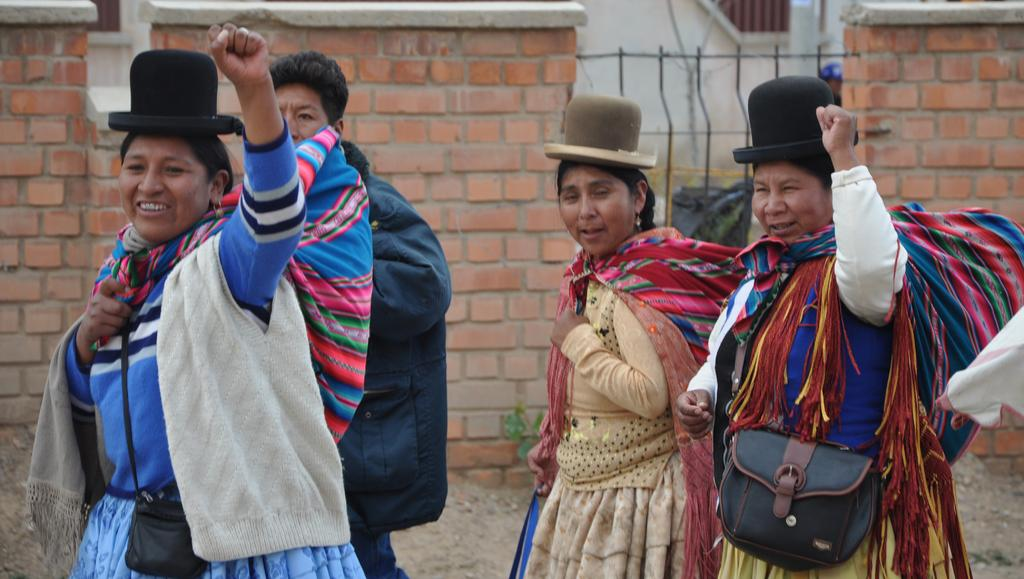Who or what can be seen in the image? There are people in the image. What are some of the people doing in the image? Some people in the image are carrying sacks. What can be seen in the background of the image? Walls, leaves, and a fence are visible in the background of the image. What type of basketball game is being played in the image? There is no basketball game present in the image. What kind of quilt is being used to cover the people in the image? There is no quilt present in the image. 